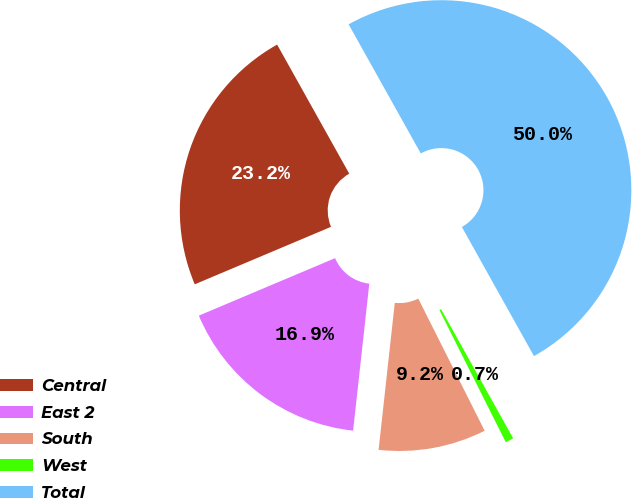<chart> <loc_0><loc_0><loc_500><loc_500><pie_chart><fcel>Central<fcel>East 2<fcel>South<fcel>West<fcel>Total<nl><fcel>23.24%<fcel>16.9%<fcel>9.15%<fcel>0.7%<fcel>50.0%<nl></chart> 